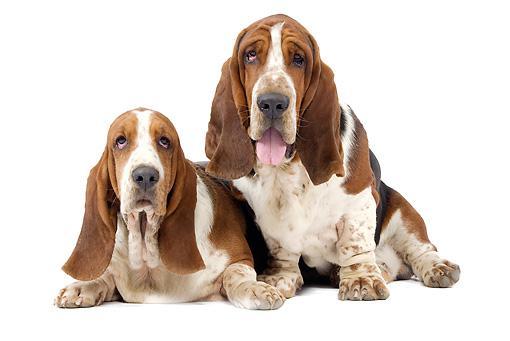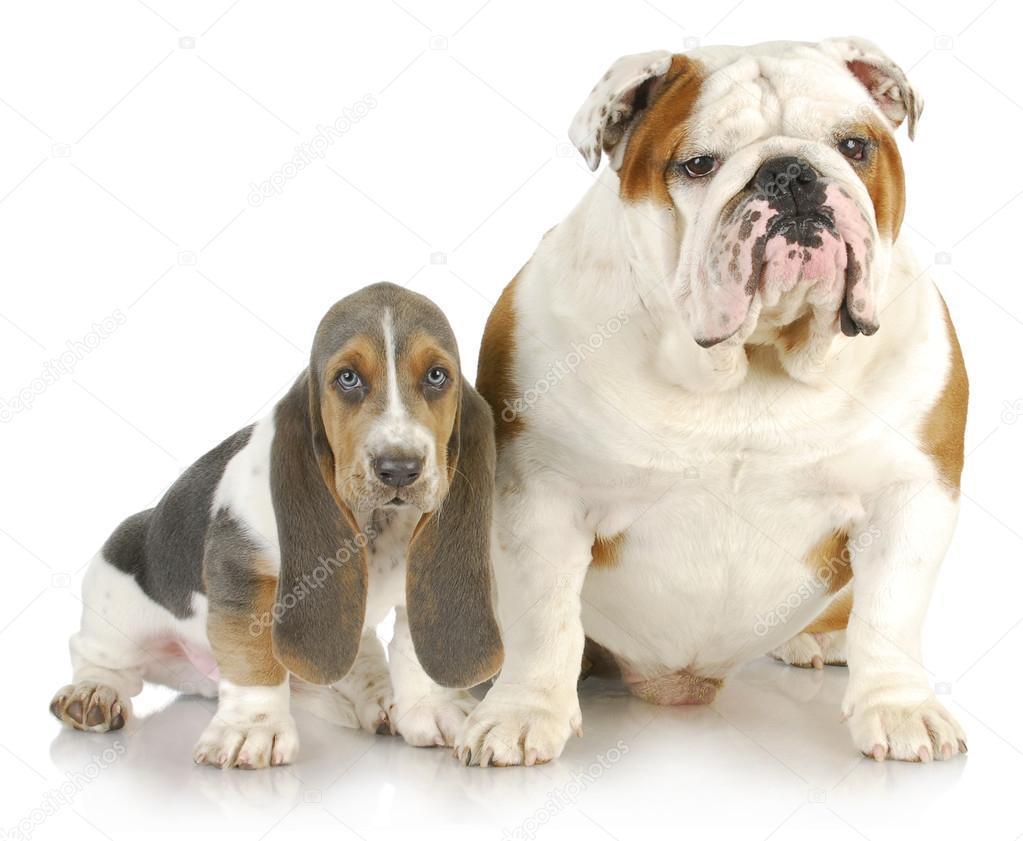The first image is the image on the left, the second image is the image on the right. Considering the images on both sides, is "An image shows a long-eared basset hound posed next to another type of pet." valid? Answer yes or no. Yes. The first image is the image on the left, the second image is the image on the right. Evaluate the accuracy of this statement regarding the images: "Two dogs with brown and white coloring are in each image, sitting side by side, with the head of one higher, and front paws forward and flat.". Is it true? Answer yes or no. Yes. 